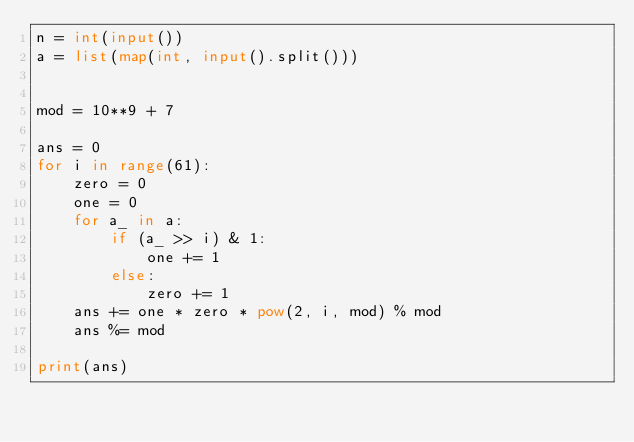Convert code to text. <code><loc_0><loc_0><loc_500><loc_500><_Python_>n = int(input())
a = list(map(int, input().split()))


mod = 10**9 + 7

ans = 0
for i in range(61):
    zero = 0
    one = 0
    for a_ in a:
        if (a_ >> i) & 1:
            one += 1
        else:
            zero += 1
    ans += one * zero * pow(2, i, mod) % mod
    ans %= mod

print(ans)</code> 